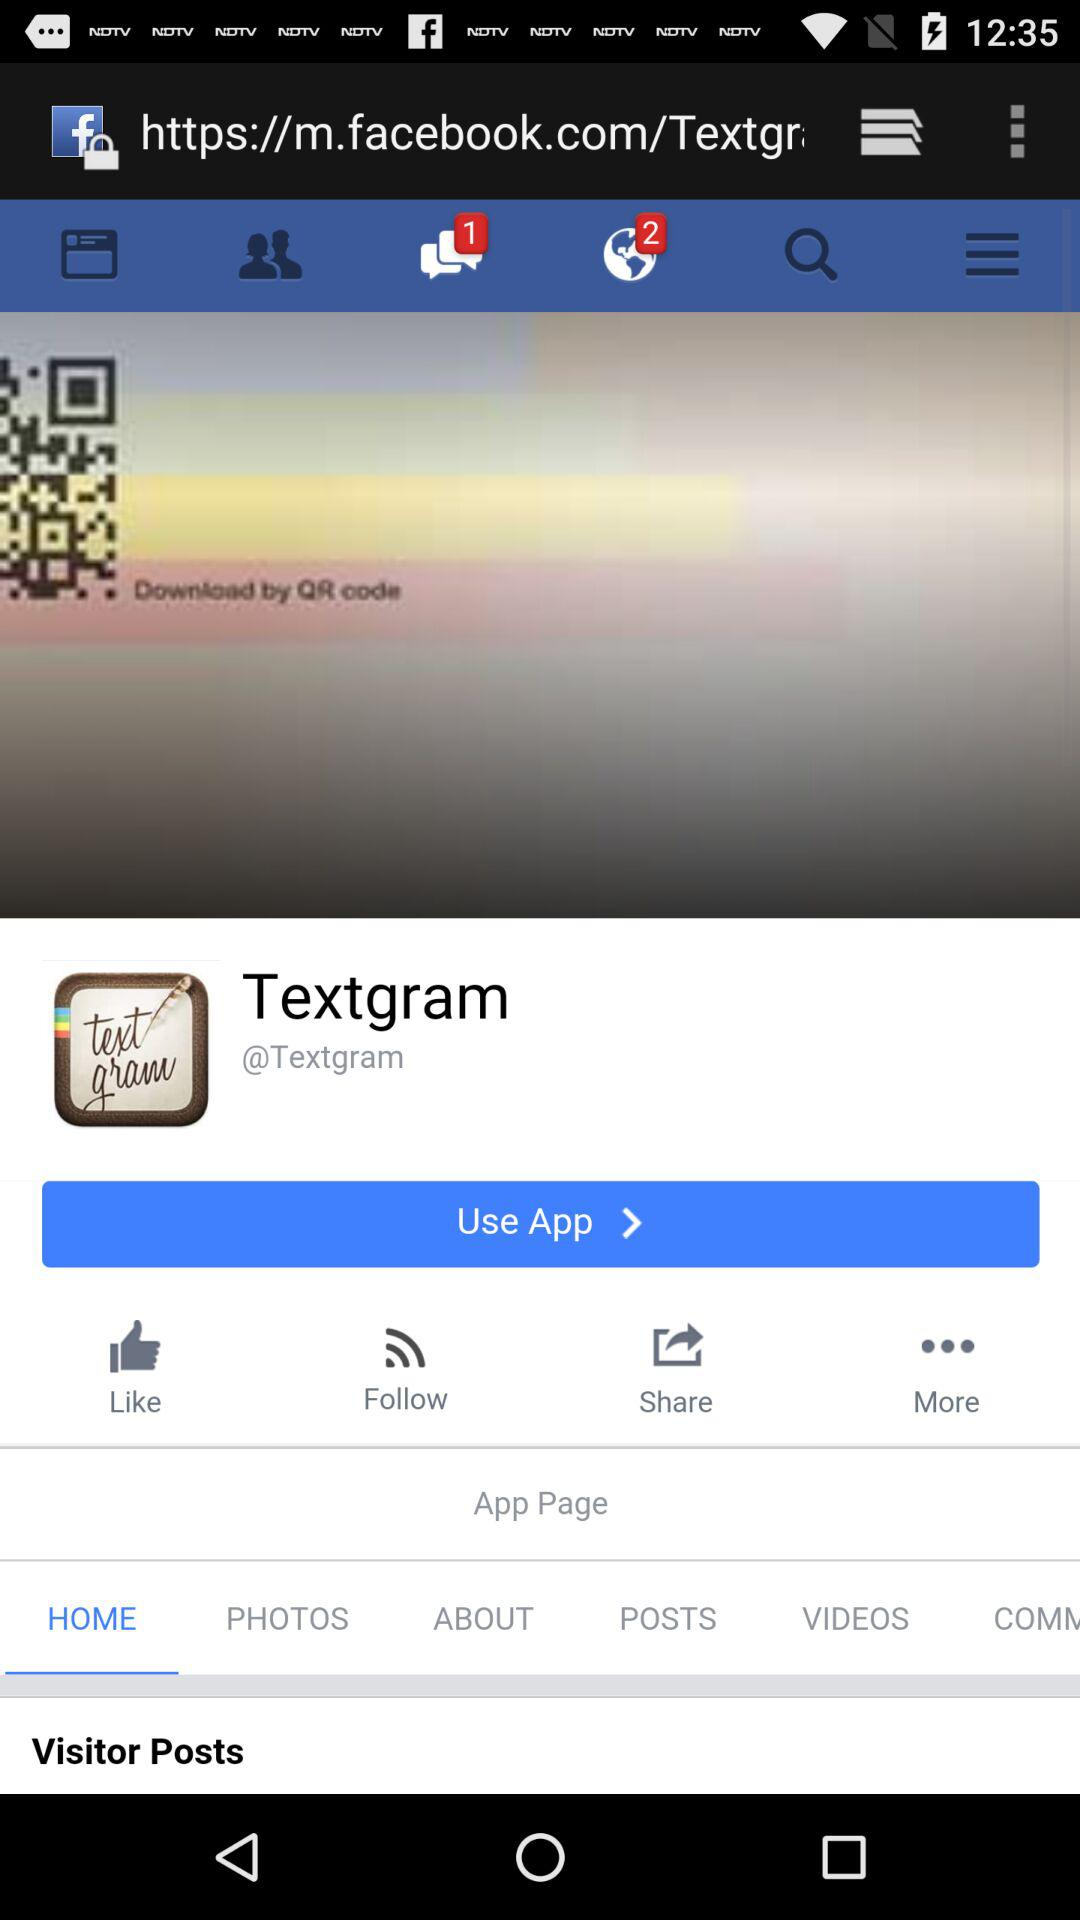How many new notifications are there? There are 2 new notifications. 